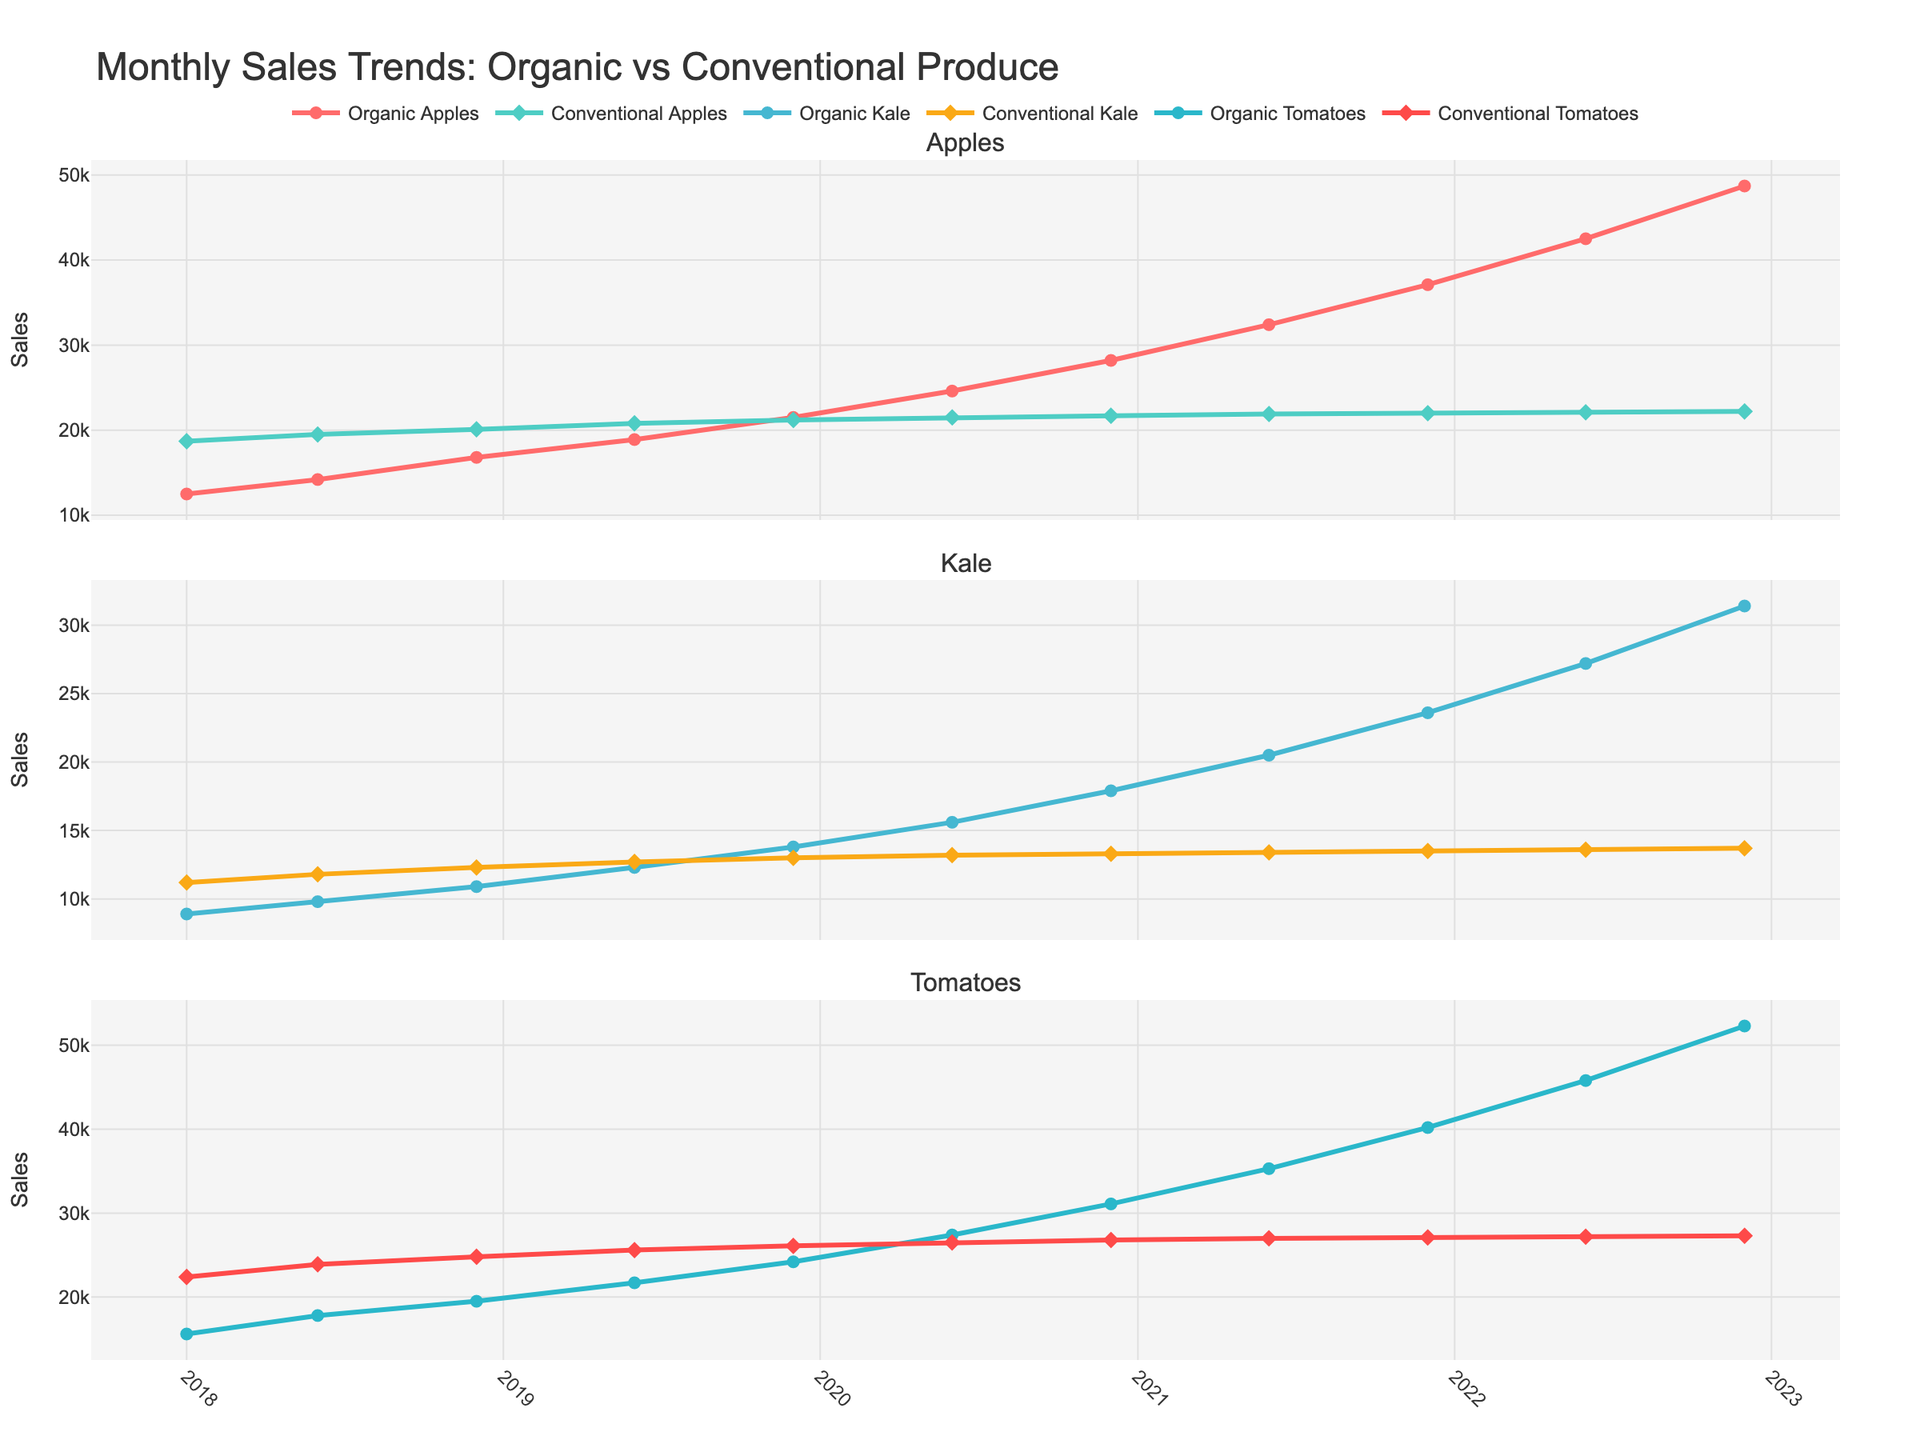What's the trend of sales for Organic Apples over the past 5 years? From January 2018 to December 2022, the sales of Organic Apples show a continuous increasing trend, starting from 12,500 in January 2018 and reaching 48,700 in December 2022.
Answer: Increasing Which product shows the largest gap between organic and conventional sales in December 2022? In December 2022, the difference between organic and conventional sales for each product is calculated as follows: Apples (48,700 - 22,200) = 26,500, Kale (31,400 - 13,700) = 17,700, Tomatoes (52,300 - 27,300) = 25,000. Therefore, Organic Apples show the largest gap.
Answer: Organic Apples In which month and year did Conventional Apples reach their peak sales? By examining the plot, the highest sales of Conventional Apples were in December 2018, where the sales reached 20,100.
Answer: December 2018 What is the average sales difference between Organic and Conventional Kale over the entire time period? Calculate the difference for each month and average them: (8900-11200 + 9800-11800 + 10900-12300 + 12300-12700 + 13800-13000 + 15600-13200 + 17900-13300 + 20500-13400 + 23600-13500 + 27200-13600 + 31400-13700) / 11 = (-2300 + -2000 + -1400 + -400 + 800 + 2400 + 4600 + 7100 + 10100 + 13600 + 17700) / 11 = 39,900 / 11 ≈ 3636.36.
Answer: ~3636.36 How do the seasonal trends compare for Organic Tomatoes between June and December of each year? For each year: 2018 (June: 17800, December: 19500, increase), 2019 (June: 21700, December: 24200, increase), 2020 (June: 27400, December: 31100, increase), 2021 (June: 35300, December: 40200, increase), 2022 (June: 45800, December: 52300, increase). The sales consistently increase from June to December in Organic Tomatoes each year.
Answer: Increase each year Which product shows a steadier increase between Organic Kale and Organic Tomatoes? By observing the plot, the line representing Organic Tomatoes shows a more gradual and steady increase compared to the line for Organic Kale, which has a more fluctuating pattern.
Answer: Organic Tomatoes What is the maximum percentage growth observed for Conventional Kale from one month to the next? Calculate the percentage growth for each increment month: [(11800-11200)/11200]*100 ≈ 5.36%, [(12300-11800)/11800]*100 ≈ 4.24%, [(12700-12300)/12300]*100 ≈ 3.25%, [(13000-12700)/12700]*100 ≈ 2.36%, [(13200-13000)/13000]*100 ≈ 1.54%, [(13300-13200)/13200]*100 ≈ 0.76%, [(13400-13300)/13300]*100 ≈ 0.75%, [(13500-13400)/13400]*100 ≈ 0.75%, [(13600-13500)/13500]*100 ≈ 0.74%, [(13700-13600)/13600]*100 ≈ 0.74%. The maximum percentage growth observed is about 5.36%.
Answer: ~5.36% What is the overall trend for Conventional Tomatoes sales over the entire period? Looking at the plot, the sales of Conventional Tomatoes show a very slight and almost negligible increasing trend from January 2018 to December 2022. Starting from 22,400 in January 2018 and increasing to 27,300 in December 2022.
Answer: Slight Increase Which month and year had the highest increase for Organic Apples compared to the previous period? By observing the plot and calculating the differences: Jun 2018 vs Jan 2018: +1700, Dec 2018 vs Jun 2018: +2600, Jun 2019 vs Dec 2018: +2100, Dec 2019 vs Jun 2019: +2600, Jun 2020 vs Dec 2019: +3100, Dec 2020 vs Jun 2020: +3600, Jun 2021 vs Dec 2020: +4200, Dec 2021 vs Jun 2021: +4700, Jun 2022 vs Dec 2021: +5400, and Dec 2022 vs Jun 2022: +6200. The highest increase occurred from June to December 2022.
Answer: December 2022 